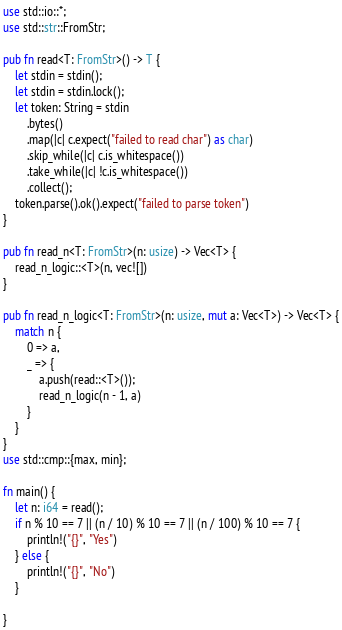Convert code to text. <code><loc_0><loc_0><loc_500><loc_500><_Rust_>use std::io::*;
use std::str::FromStr;

pub fn read<T: FromStr>() -> T {
    let stdin = stdin();
    let stdin = stdin.lock();
    let token: String = stdin
        .bytes()
        .map(|c| c.expect("failed to read char") as char)
        .skip_while(|c| c.is_whitespace())
        .take_while(|c| !c.is_whitespace())
        .collect();
    token.parse().ok().expect("failed to parse token")
}

pub fn read_n<T: FromStr>(n: usize) -> Vec<T> {
    read_n_logic::<T>(n, vec![])
}

pub fn read_n_logic<T: FromStr>(n: usize, mut a: Vec<T>) -> Vec<T> {
    match n {
        0 => a,
        _ => {
            a.push(read::<T>());
            read_n_logic(n - 1, a)
        }
    }
}
use std::cmp::{max, min};

fn main() {
    let n: i64 = read();
    if n % 10 == 7 || (n / 10) % 10 == 7 || (n / 100) % 10 == 7 {
        println!("{}", "Yes")
    } else {
        println!("{}", "No")
    }

}
</code> 